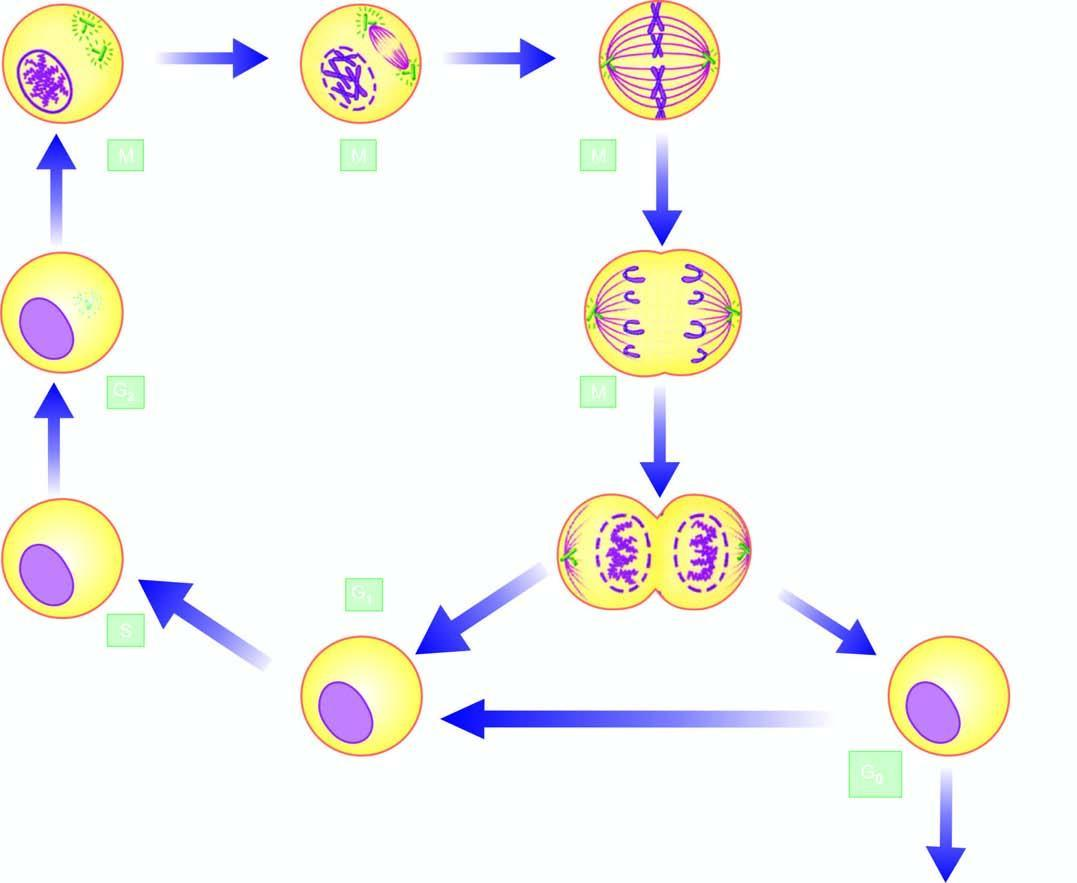what are premitotic phases while m phase is accomplished in 4 sequential stages: prophase, metaphase, anaphase, and telophase?
Answer the question using a single word or phrase. The g1 